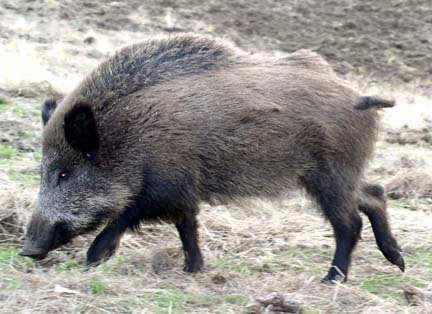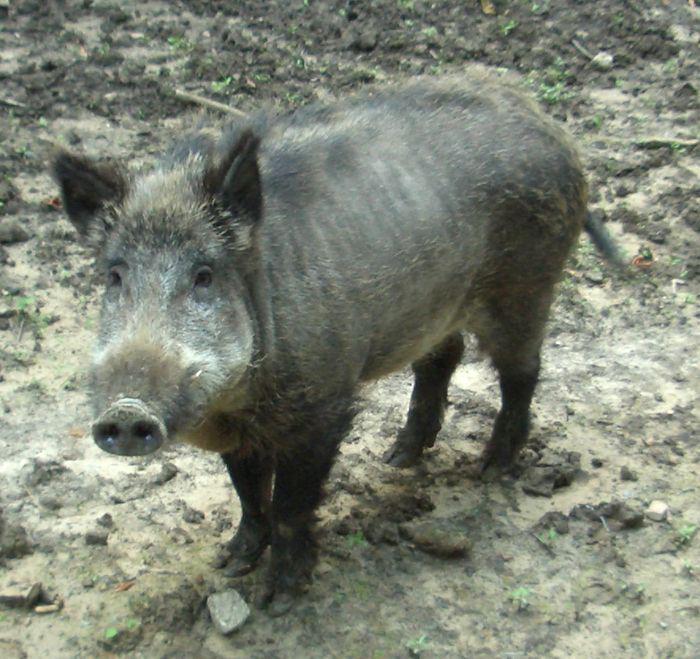The first image is the image on the left, the second image is the image on the right. For the images shown, is this caption "The animal in the image on the right is facing right." true? Answer yes or no. No. 